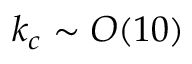Convert formula to latex. <formula><loc_0><loc_0><loc_500><loc_500>k _ { c } \sim O ( 1 0 )</formula> 